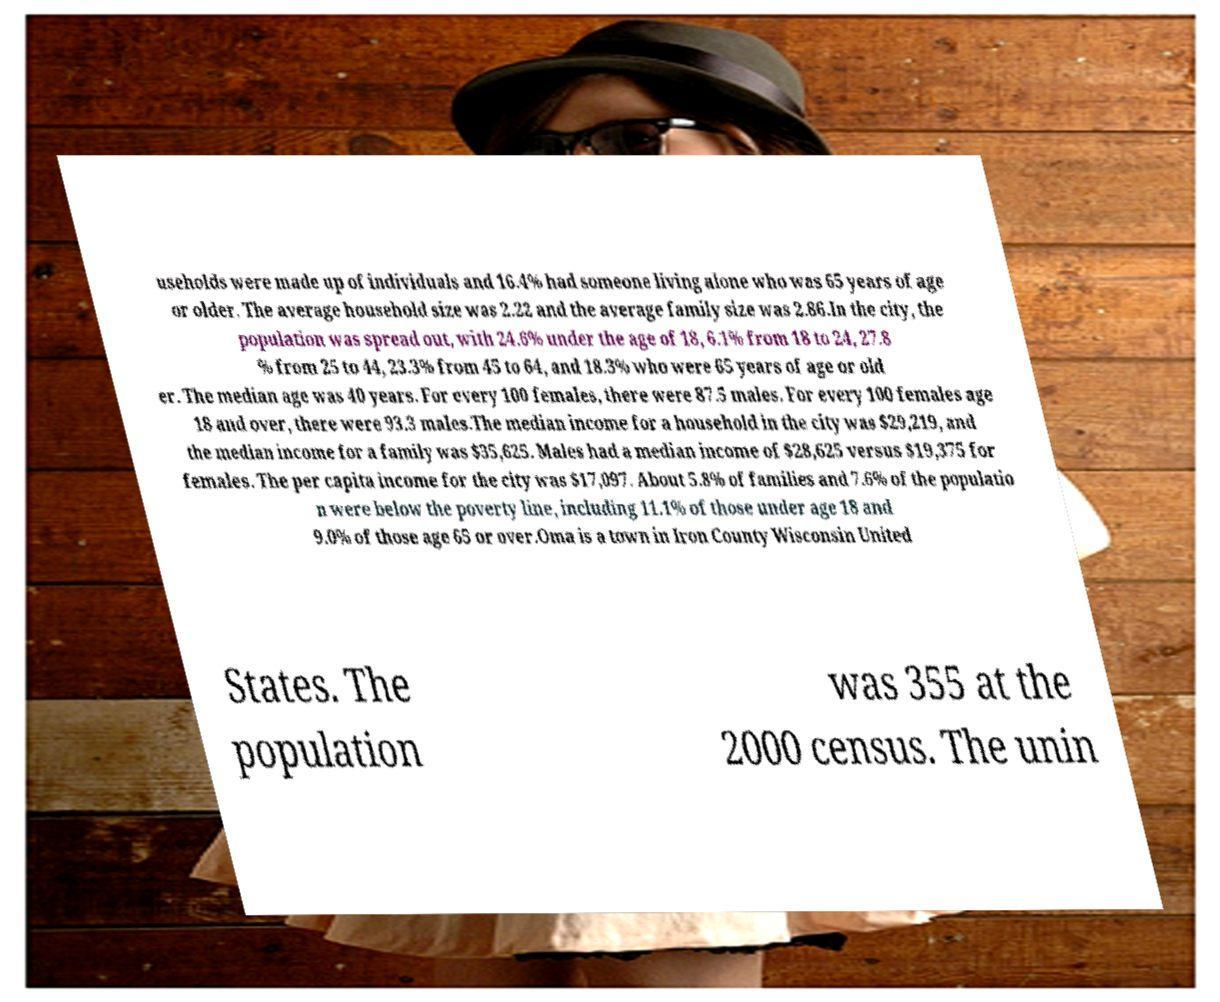For documentation purposes, I need the text within this image transcribed. Could you provide that? useholds were made up of individuals and 16.4% had someone living alone who was 65 years of age or older. The average household size was 2.22 and the average family size was 2.86.In the city, the population was spread out, with 24.6% under the age of 18, 6.1% from 18 to 24, 27.8 % from 25 to 44, 23.3% from 45 to 64, and 18.3% who were 65 years of age or old er. The median age was 40 years. For every 100 females, there were 87.5 males. For every 100 females age 18 and over, there were 93.3 males.The median income for a household in the city was $29,219, and the median income for a family was $35,625. Males had a median income of $28,625 versus $19,375 for females. The per capita income for the city was $17,097. About 5.8% of families and 7.6% of the populatio n were below the poverty line, including 11.1% of those under age 18 and 9.0% of those age 65 or over.Oma is a town in Iron County Wisconsin United States. The population was 355 at the 2000 census. The unin 